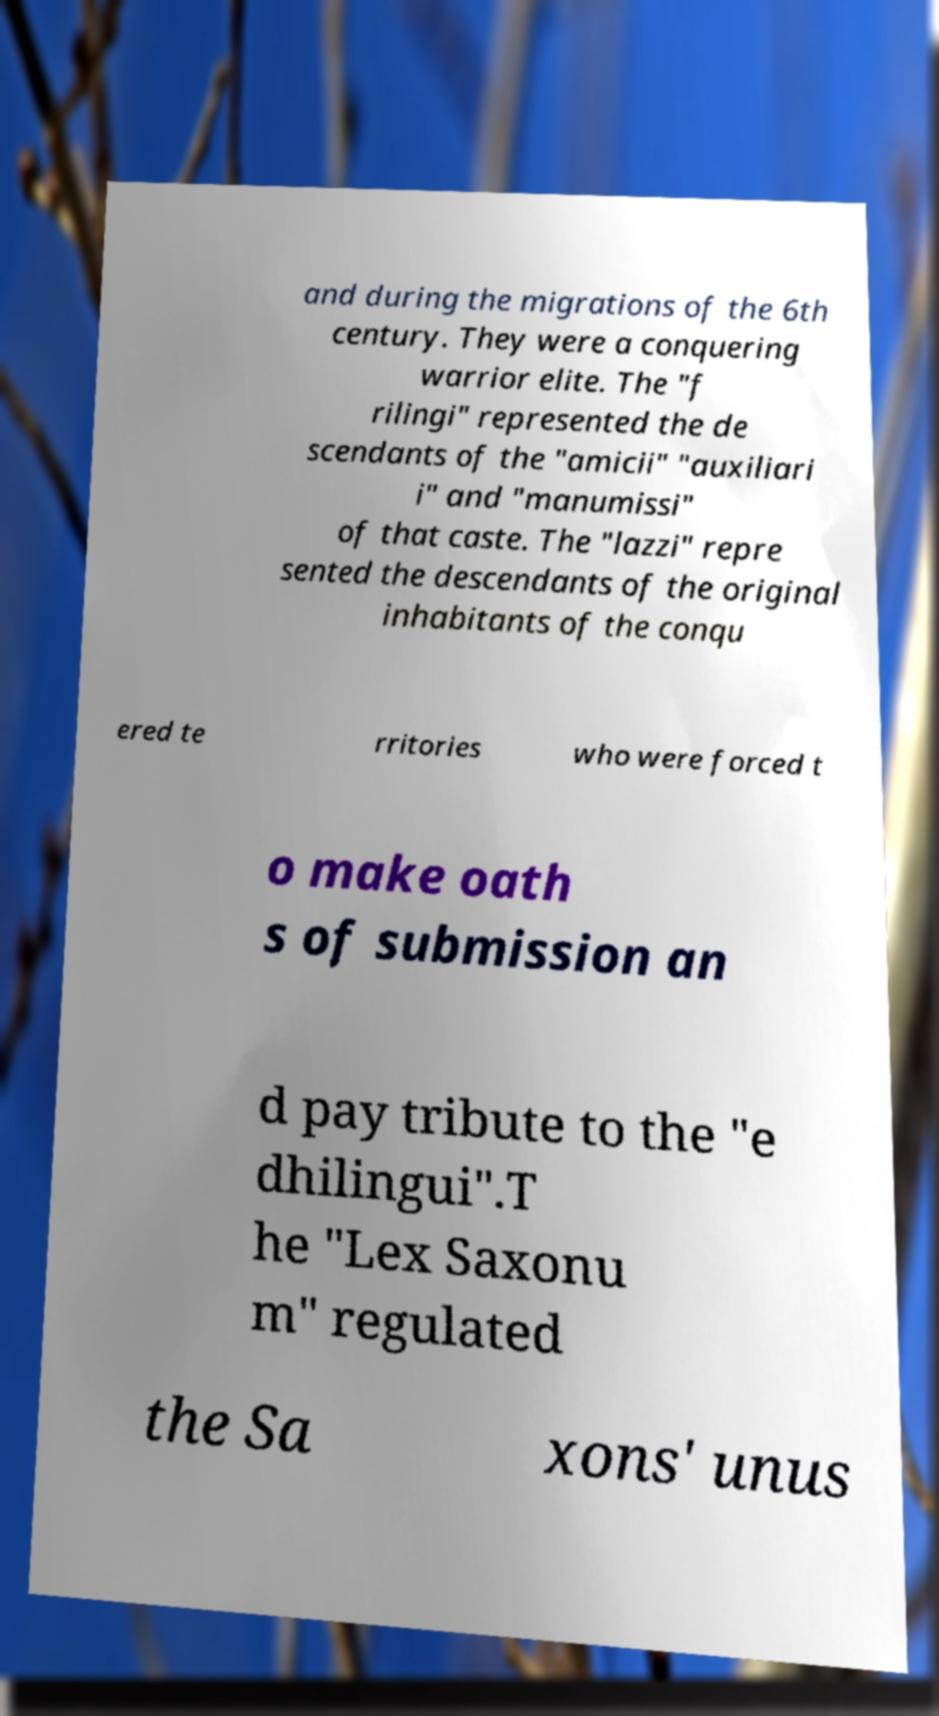For documentation purposes, I need the text within this image transcribed. Could you provide that? and during the migrations of the 6th century. They were a conquering warrior elite. The "f rilingi" represented the de scendants of the "amicii" "auxiliari i" and "manumissi" of that caste. The "lazzi" repre sented the descendants of the original inhabitants of the conqu ered te rritories who were forced t o make oath s of submission an d pay tribute to the "e dhilingui".T he "Lex Saxonu m" regulated the Sa xons' unus 